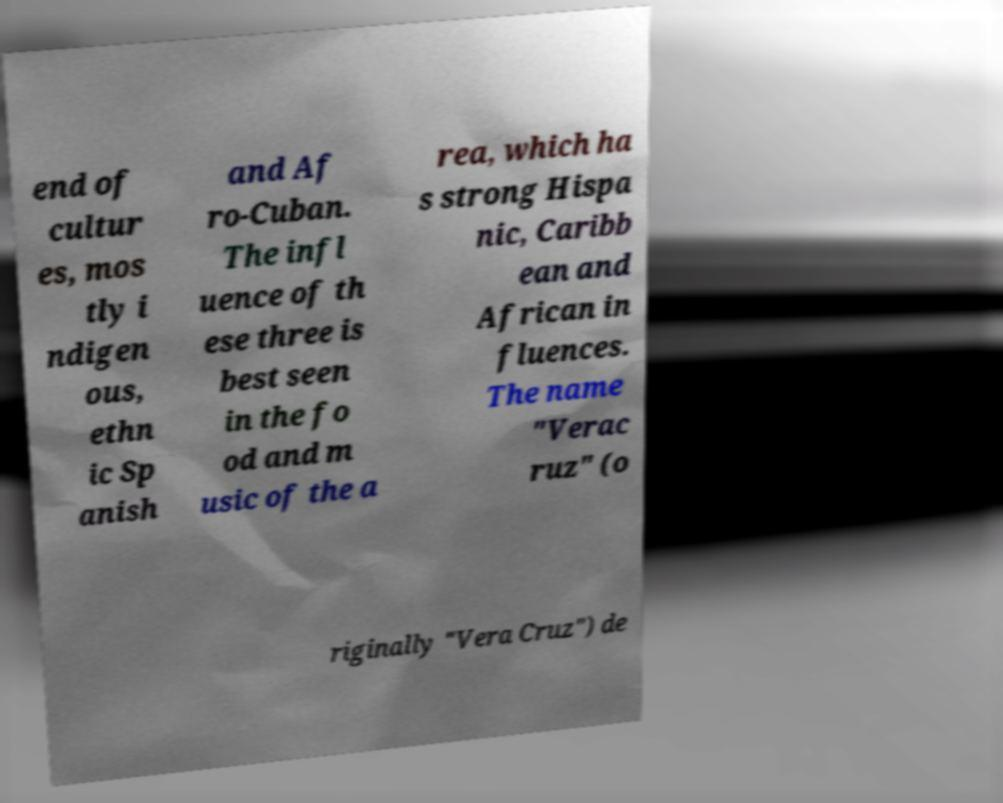Please identify and transcribe the text found in this image. end of cultur es, mos tly i ndigen ous, ethn ic Sp anish and Af ro-Cuban. The infl uence of th ese three is best seen in the fo od and m usic of the a rea, which ha s strong Hispa nic, Caribb ean and African in fluences. The name "Verac ruz" (o riginally "Vera Cruz") de 